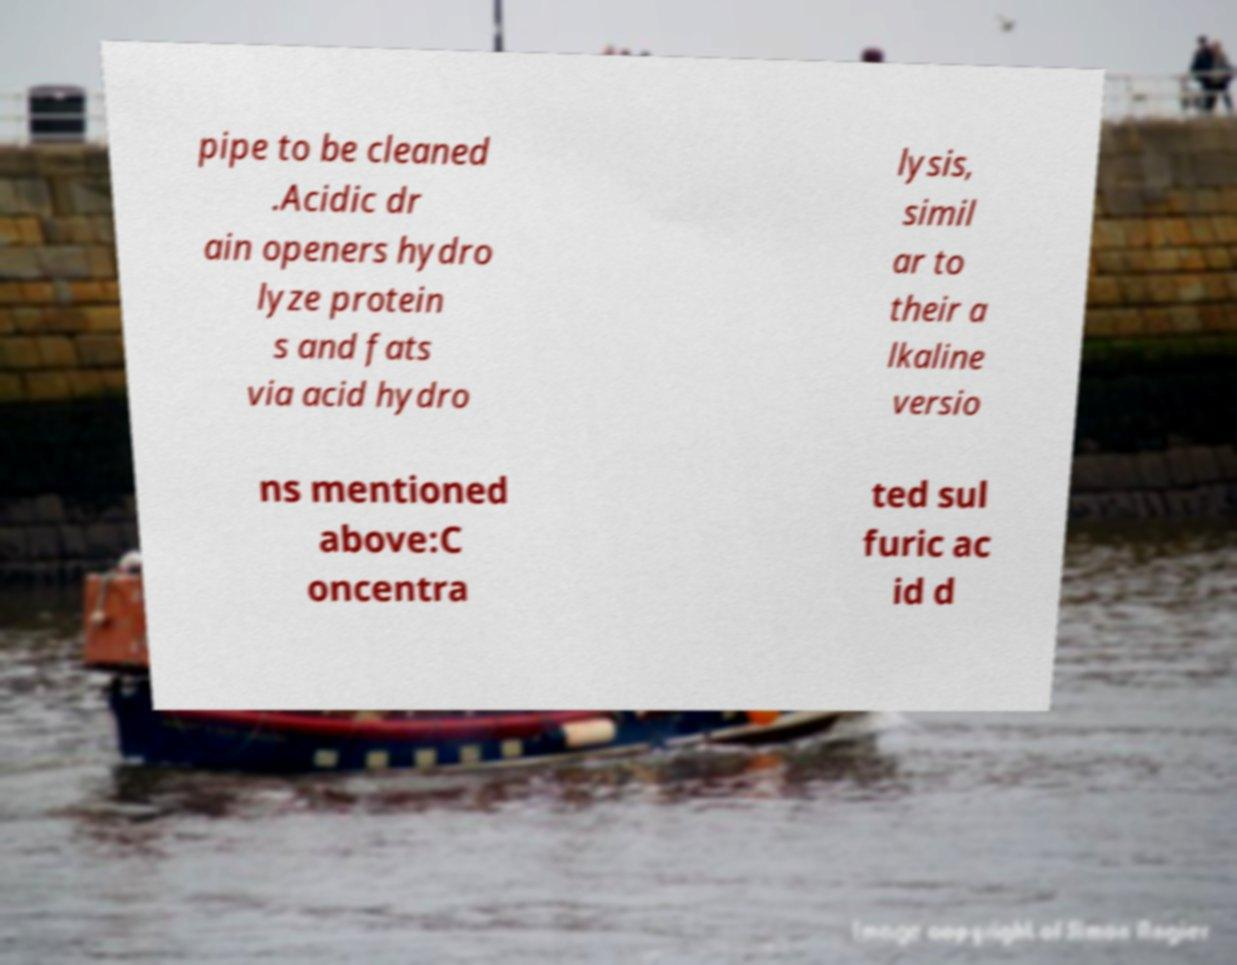Please read and relay the text visible in this image. What does it say? pipe to be cleaned .Acidic dr ain openers hydro lyze protein s and fats via acid hydro lysis, simil ar to their a lkaline versio ns mentioned above:C oncentra ted sul furic ac id d 